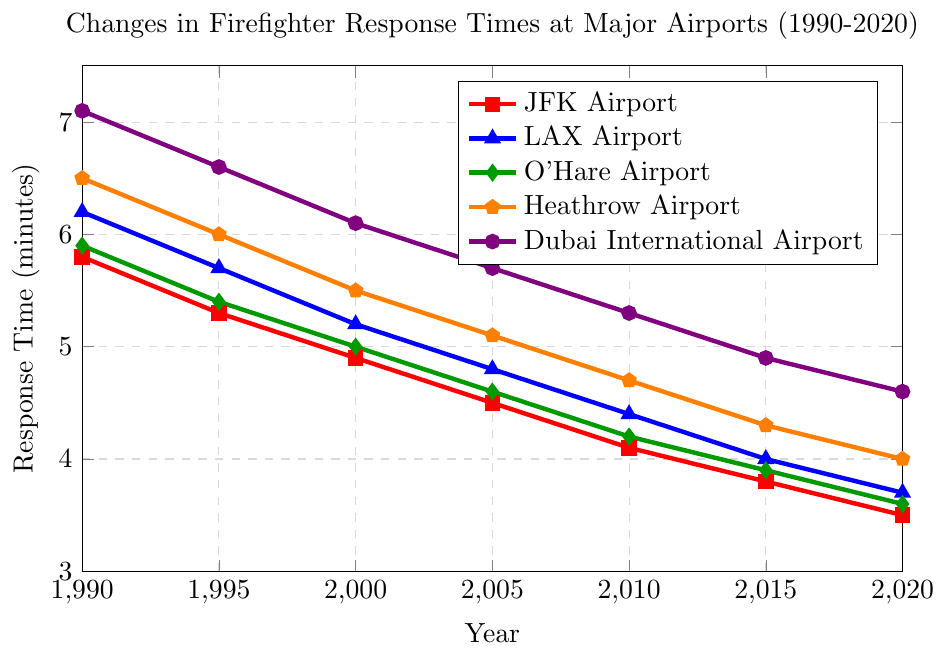What is the trend of response times for JFK Airport from 1990 to 2020? The response time for JFK Airport in 1990 was 5.8 minutes and it gradually decreased over the years, reaching 3.5 minutes in 2020.
Answer: It has a decreasing trend Which airport had the longest response time in 1990 and what was the exact value? In 1990, Dubai International Airport had the longest response time, which was 7.1 minutes.
Answer: Dubai International Airport, 7.1 minutes How much did the response time at Heathrow Airport reduce from 1990 to 2020? The response time at Heathrow Airport in 1990 was 6.5 minutes. By 2020, it was 4.0 minutes. The reduction is 6.5 - 4.0 = 2.5 minutes.
Answer: 2.5 minutes Between which two consecutive years did LAX Airport see the most significant reduction in response time? For LAX Airport, the response times were: 6.2 (1990), 5.7 (1995), 5.2 (2000), 4.8 (2005), 4.4 (2010), 4.0 (2015), and 3.7 (2020). The most significant reduction occurred between 1990 and 1995, with a decrease of 6.2 - 5.7 = 0.5 minutes.
Answer: Between 1990 and 1995 Which airport had the shortest response time in 2020 and what was it? In 2020, JFK Airport had the shortest response time, which was 3.5 minutes.
Answer: JFK Airport, 3.5 minutes What is the average response time at Dubai International Airport across all the years shown in the figure? The response times for Dubai International Airport are: 7.1, 6.6, 6.1, 5.7, 5.3, 4.9, and 4.6 minutes. The average is (7.1 + 6.6 + 6.1 + 5.7 + 5.3 + 4.9 + 4.6) / 7 = 5.4714 minutes.
Answer: Approximately 5.47 minutes Which airport's response time curve visually shows the steepest decline? By observing the slope of the response time curves, JFK Airport's curve, represented by the red line, shows the steepest decline.
Answer: JFK Airport Are there any airports whose response times crossed below 4 minutes by 2020? If yes, list them. The response times in 2020 below 4 minutes are: JFK Airport (3.5), LAX Airport (3.7), and O'Hare Airport (3.6).
Answer: Yes, JFK Airport, LAX Airport, and O'Hare Airport Compare the response times of Heathrow Airport and O'Hare Airport in 2005. Which one was faster and by how much? In 2005, the response time for Heathrow Airport was 5.1 minutes and for O'Hare Airport was 4.6 minutes. O'Hare Airport was faster by 5.1 - 4.6 = 0.5 minutes.
Answer: O'Hare Airport, by 0.5 minutes 